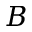Convert formula to latex. <formula><loc_0><loc_0><loc_500><loc_500>B</formula> 